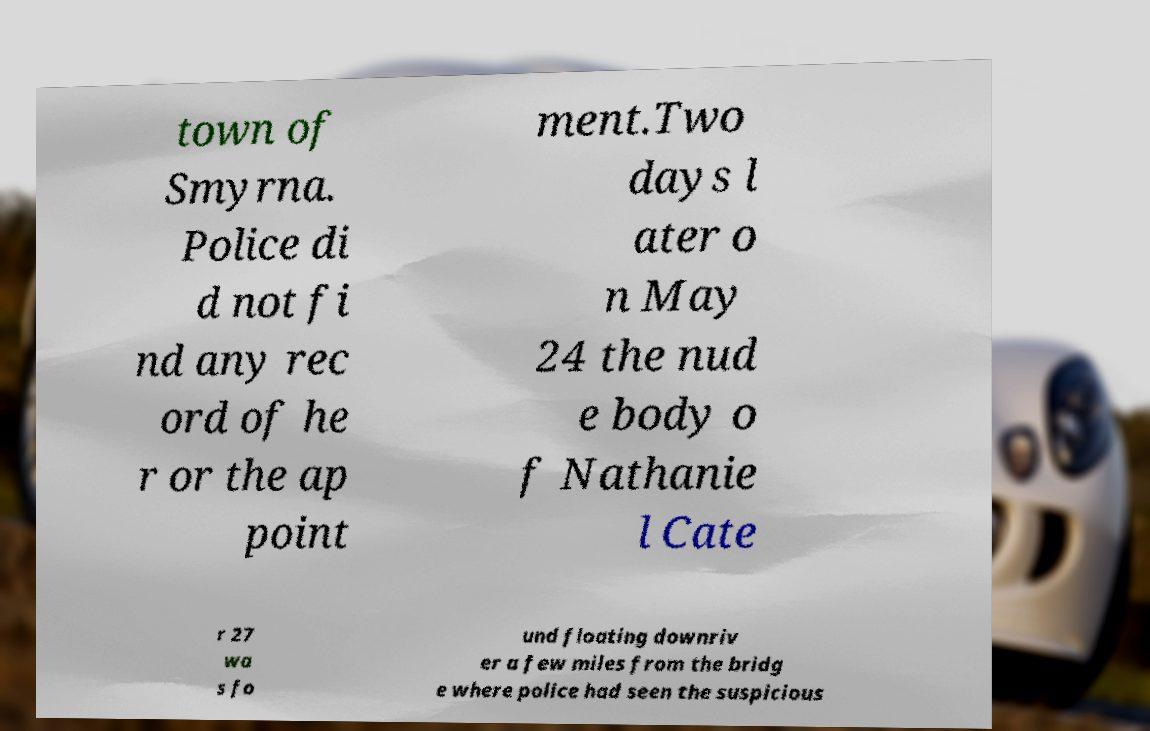Could you extract and type out the text from this image? town of Smyrna. Police di d not fi nd any rec ord of he r or the ap point ment.Two days l ater o n May 24 the nud e body o f Nathanie l Cate r 27 wa s fo und floating downriv er a few miles from the bridg e where police had seen the suspicious 